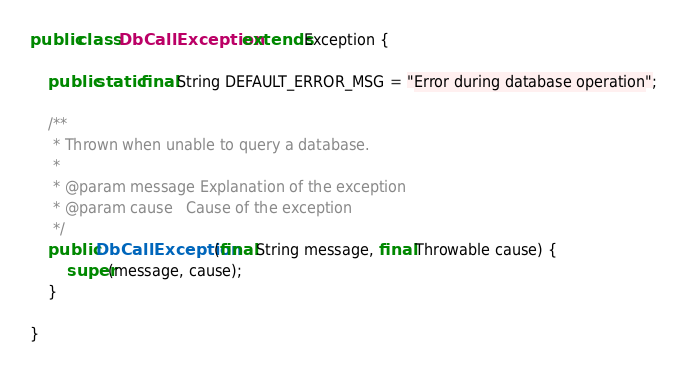Convert code to text. <code><loc_0><loc_0><loc_500><loc_500><_Java_>public class DbCallException extends Exception {

    public static final String DEFAULT_ERROR_MSG = "Error during database operation";

    /**
     * Thrown when unable to query a database.
     *
     * @param message Explanation of the exception
     * @param cause   Cause of the exception
     */
    public DbCallException(final String message, final Throwable cause) {
        super(message, cause);
    }

}
</code> 